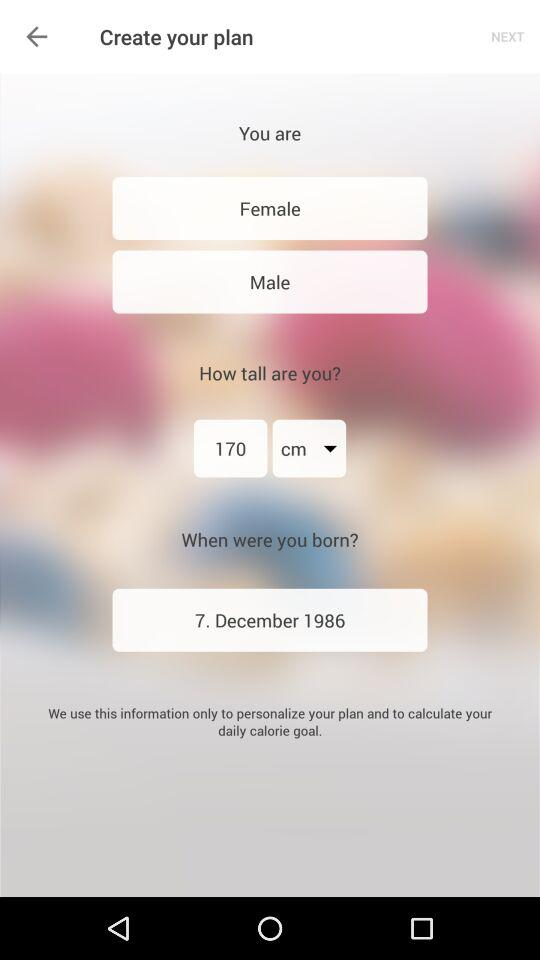What is the height? The height is 170 cm. 